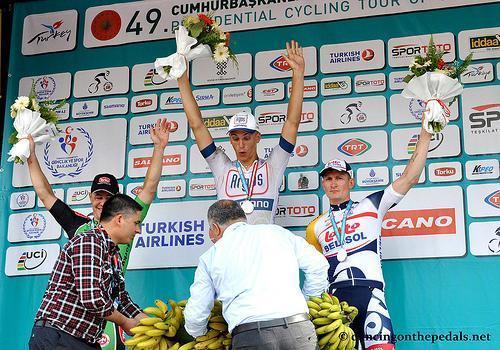How many people are in the picture?
Give a very brief answer. 5. How many hands are in the air?
Give a very brief answer. 5. 